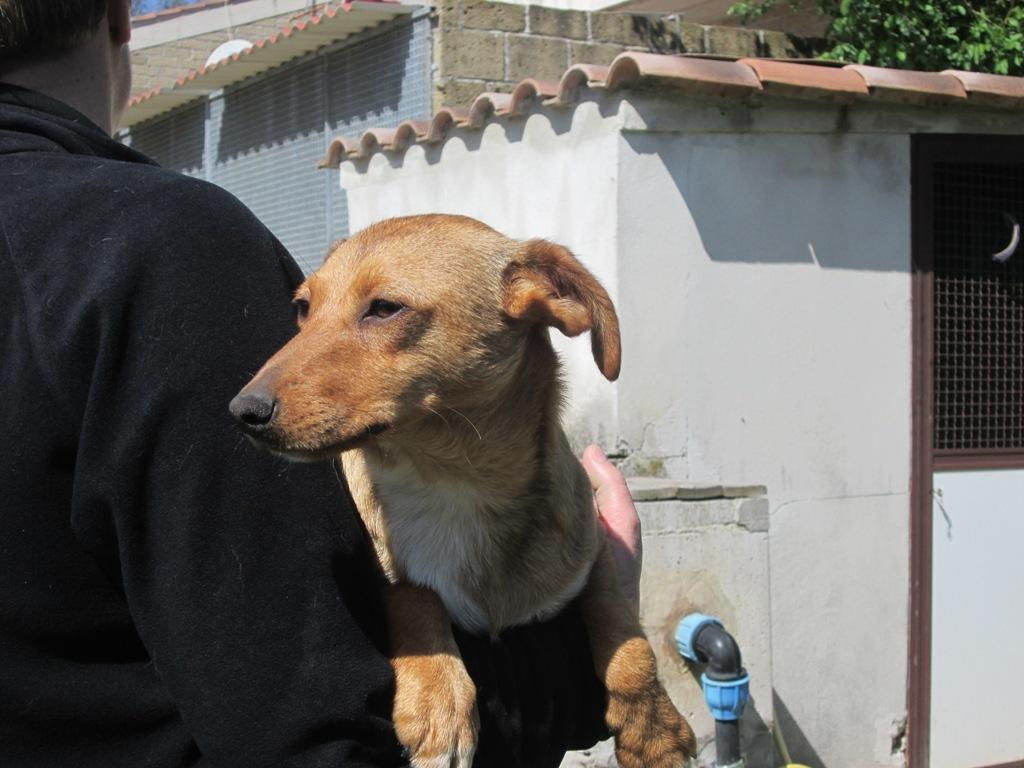What type of buildings can be seen in the image? There are houses in the image. What animal is present in the image? There is a dog in the image. What utility object can be seen in the image? There is a water pipe in the image. What type of plant is visible in the image? There is a tree in the image. What type of barrier is present in the image? There is a fence in the image. What is the man in the image wearing? The man in the image is wearing a black color dress. What type of covering is present on the window in the image? There is a rolling shutter in the image. Can you tell me how many robins are perched on the fence in the image? There are no robins present in the image; it features a dog, houses, a water pipe, a tree, a fence, a man wearing a black color dress, and a rolling shutter. What type of snake is slithering through the grass in the image? There is no snake present in the image; it features a dog, houses, a water pipe, a tree, a fence, a man wearing a black color dress, and a rolling shutter. 